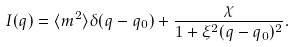<formula> <loc_0><loc_0><loc_500><loc_500>I ( { q } ) = \langle m ^ { 2 } \rangle \delta ( { q } - { q } _ { 0 } ) + \frac { \chi } { 1 + \xi ^ { 2 } ( { q } - { q } _ { 0 } ) ^ { 2 } } .</formula> 